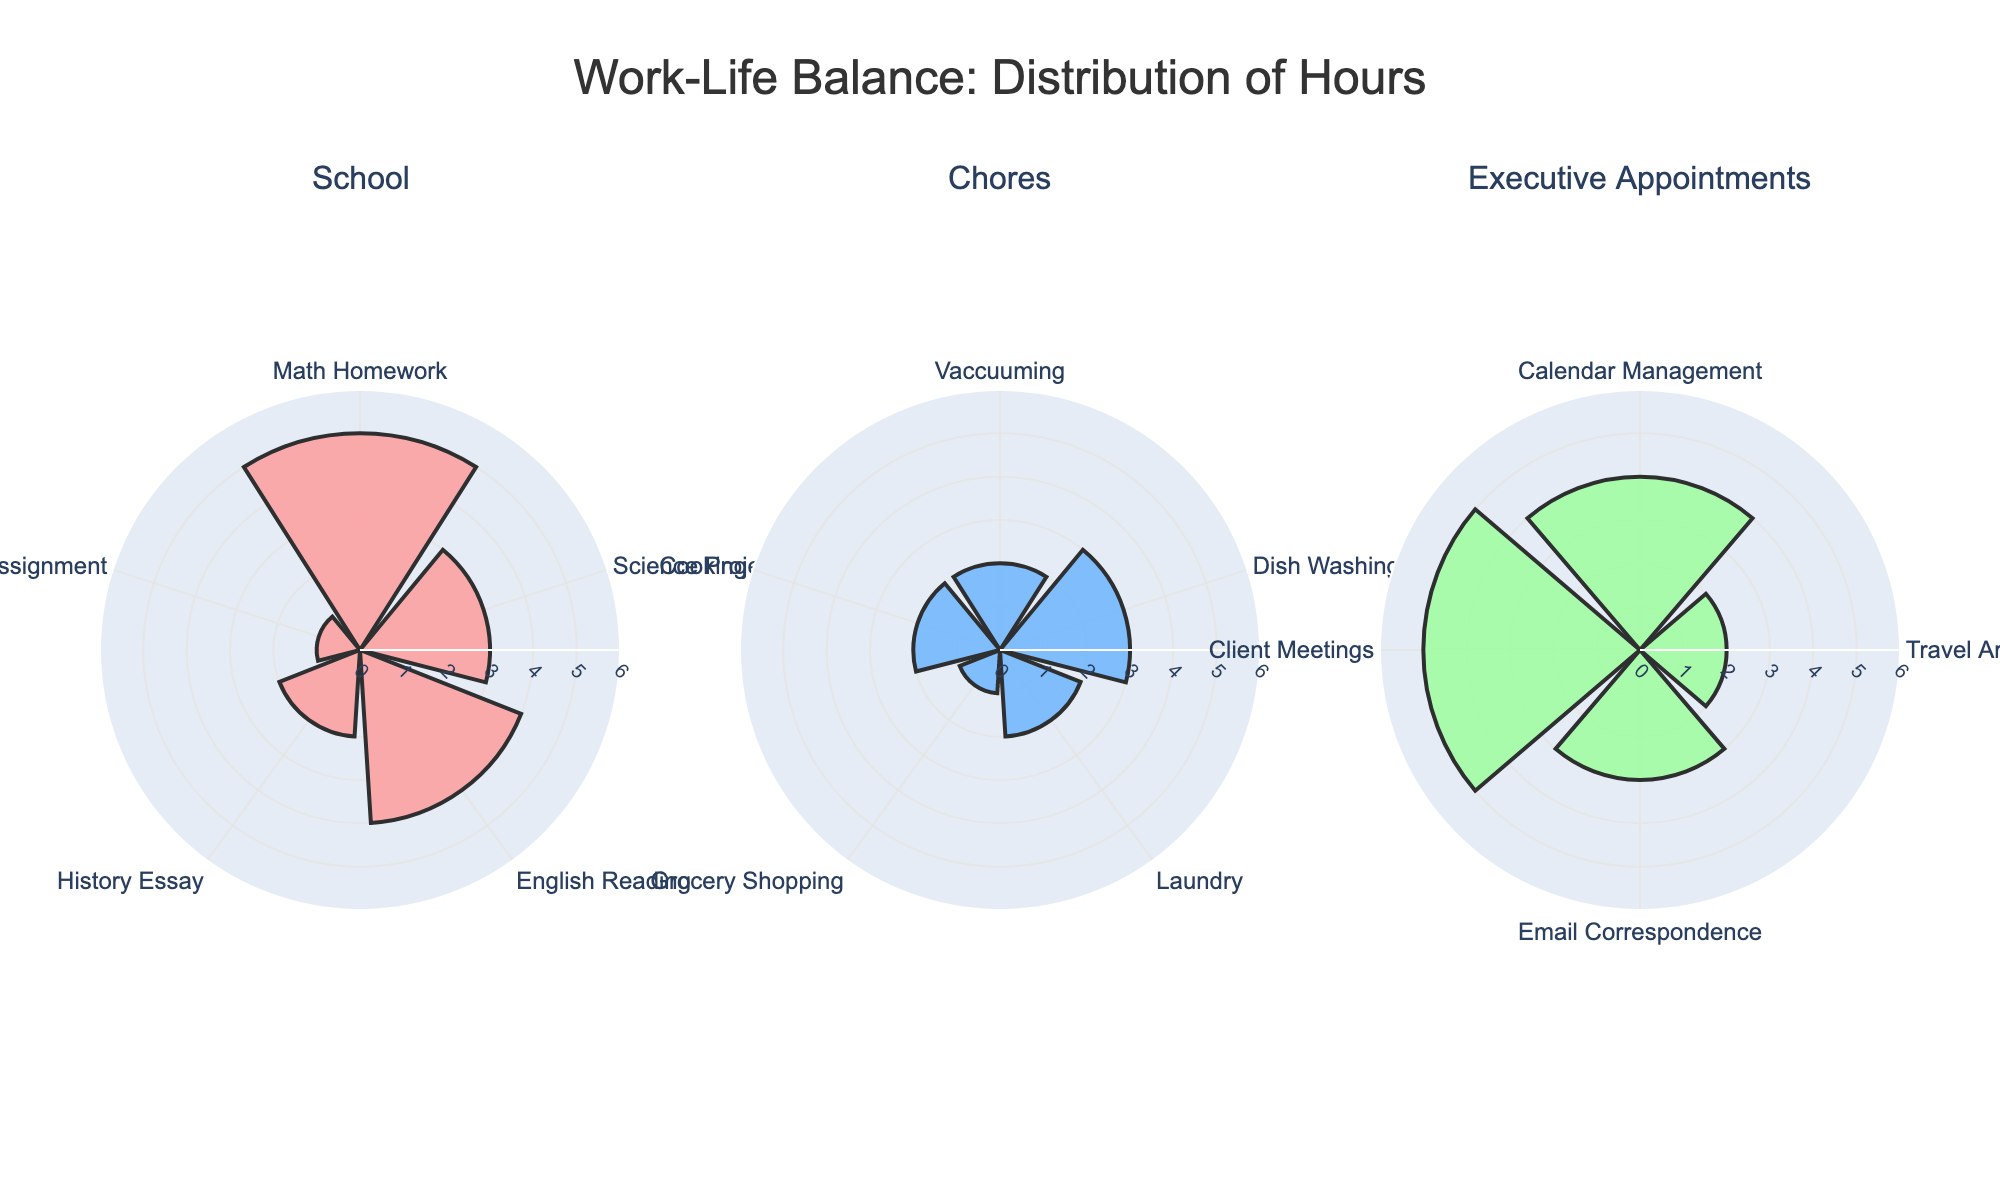How many activities are displayed in the "School" category? Count the number of unique activities listed under the "School" section of the polar bar chart.
Answer: 5 Which activity in the "Chores" category takes the most time? Identify the activity under the "Chores" section that has the longest bar indicating the highest hours spent.
Answer: Dish Washing What's the total number of hours spent on "Executive Appointments" activities? Sum up all the hour values for activities under the "Executive Appointments" category: 4 + 2 + 3 + 5.
Answer: 14 How does the time spent on "Vaccuuming" compare to "Cooking"? Compare the bar lengths for "Vaccuuming" and "Cooking" under the "Chores" category; both bars should be nearly equal.
Answer: Equal What is the range of hours spent across all activities in the "Chores" category? Find the minimum and maximum values of hours spent on activities in "Chores": minimum is 1 (Grocery Shopping) and maximum is 3 (Dish Washing). The range is 3 - 1.
Answer: 2 What's the average time spent on each activity in the "School" category? Add up all hours spent on "School" activities (5+3+4+2+1 = 15) and divide by the number of activities (5).
Answer: 3 Which category shows the highest overall sum of hours? Compare total hours summed for each category: School (15), Chores (10), Executive Appointments (14).
Answer: School Are there any activities in the "School" category that took 2 hours? If so, which one(s)? Check for any bars in the "School" section that are marked with 2 hours.
Answer: History Essay What percentage of total hours is spent on "Client Meetings" in the "Executive Appointments" category? Total hours in Executive Appointments is 14. The hours spent on Client Meetings is 5. Calculate the percentage: (5/14) * 100.
Answer: ~35.7% Compare the time spent on "Email Correspondence" with that on "Science Project". Which one is greater and by how much? Check the bar lengths for "Email Correspondence" in Executive Appointments (3 hours) and "Science Project" in School (3 hours). Calculate the difference.
Answer: They are equal 